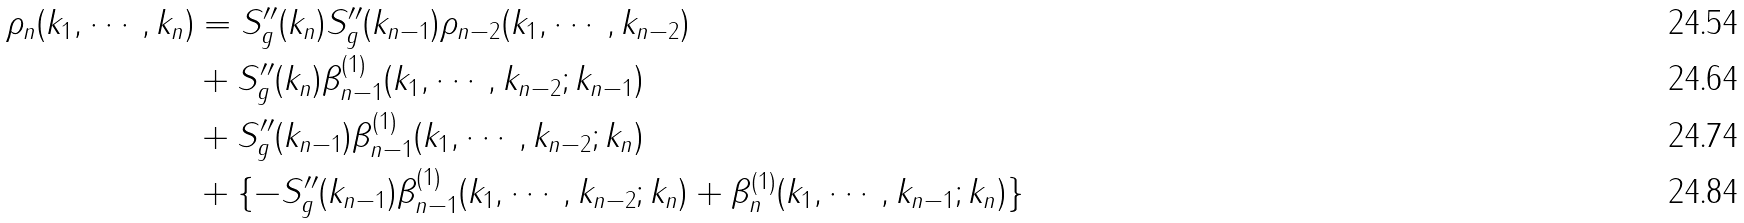<formula> <loc_0><loc_0><loc_500><loc_500>\rho _ { n } ( k _ { 1 } , \cdots , k _ { n } ) & = S ^ { \prime \prime } _ { g } ( k _ { n } ) S ^ { \prime \prime } _ { g } ( k _ { n - 1 } ) \rho _ { n - 2 } ( k _ { 1 } , \cdots , k _ { n - 2 } ) \\ & + S ^ { \prime \prime } _ { g } ( k _ { n } ) \beta ^ { ( 1 ) } _ { n - 1 } ( k _ { 1 } , \cdots , k _ { n - 2 } ; k _ { n - 1 } ) \\ & + S ^ { \prime \prime } _ { g } ( k _ { n - 1 } ) \beta ^ { ( 1 ) } _ { n - 1 } ( k _ { 1 } , \cdots , k _ { n - 2 } ; k _ { n } ) \\ & + \{ - S ^ { \prime \prime } _ { g } ( k _ { n - 1 } ) \beta ^ { ( 1 ) } _ { n - 1 } ( k _ { 1 } , \cdots , k _ { n - 2 } ; k _ { n } ) + \beta ^ { ( 1 ) } _ { n } ( k _ { 1 } , \cdots , k _ { n - 1 } ; k _ { n } ) \}</formula> 